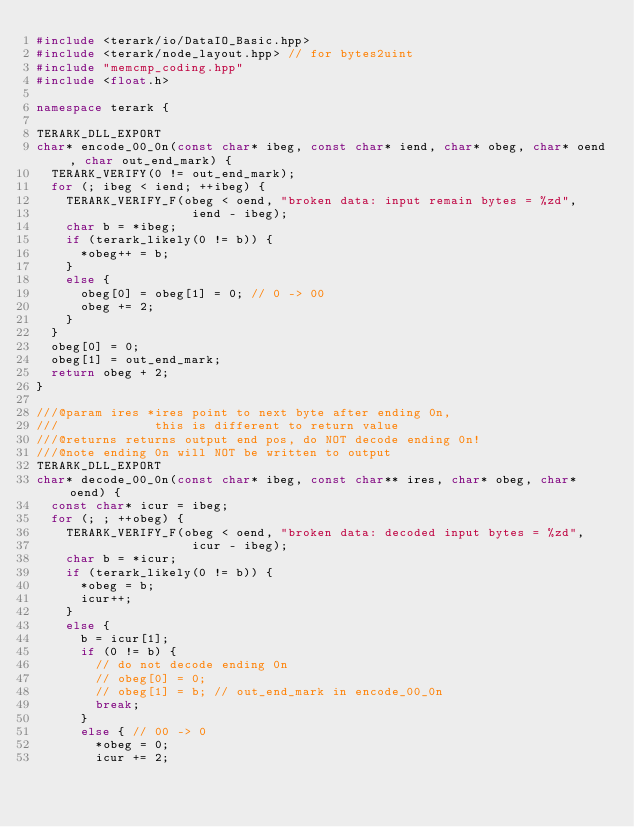Convert code to text. <code><loc_0><loc_0><loc_500><loc_500><_C++_>#include <terark/io/DataIO_Basic.hpp>
#include <terark/node_layout.hpp> // for bytes2uint
#include "memcmp_coding.hpp"
#include <float.h>

namespace terark {

TERARK_DLL_EXPORT
char* encode_00_0n(const char* ibeg, const char* iend, char* obeg, char* oend, char out_end_mark) {
  TERARK_VERIFY(0 != out_end_mark);
  for (; ibeg < iend; ++ibeg) {
    TERARK_VERIFY_F(obeg < oend, "broken data: input remain bytes = %zd",
                     iend - ibeg);
    char b = *ibeg;
    if (terark_likely(0 != b)) {
      *obeg++ = b;
    }
    else {
      obeg[0] = obeg[1] = 0; // 0 -> 00
      obeg += 2;
    }
  }
  obeg[0] = 0;
  obeg[1] = out_end_mark;
  return obeg + 2;
}

///@param ires *ires point to next byte after ending 0n,
///             this is different to return value
///@returns returns output end pos, do NOT decode ending 0n!
///@note ending 0n will NOT be written to output
TERARK_DLL_EXPORT
char* decode_00_0n(const char* ibeg, const char** ires, char* obeg, char* oend) {
  const char* icur = ibeg;
  for (; ; ++obeg) {
    TERARK_VERIFY_F(obeg < oend, "broken data: decoded input bytes = %zd",
                     icur - ibeg);
    char b = *icur;
    if (terark_likely(0 != b)) {
      *obeg = b;
      icur++;
    }
    else {
      b = icur[1];
      if (0 != b) {
        // do not decode ending 0n
        // obeg[0] = 0;
        // obeg[1] = b; // out_end_mark in encode_00_0n
        break;
      }
      else { // 00 -> 0
        *obeg = 0;
        icur += 2;</code> 